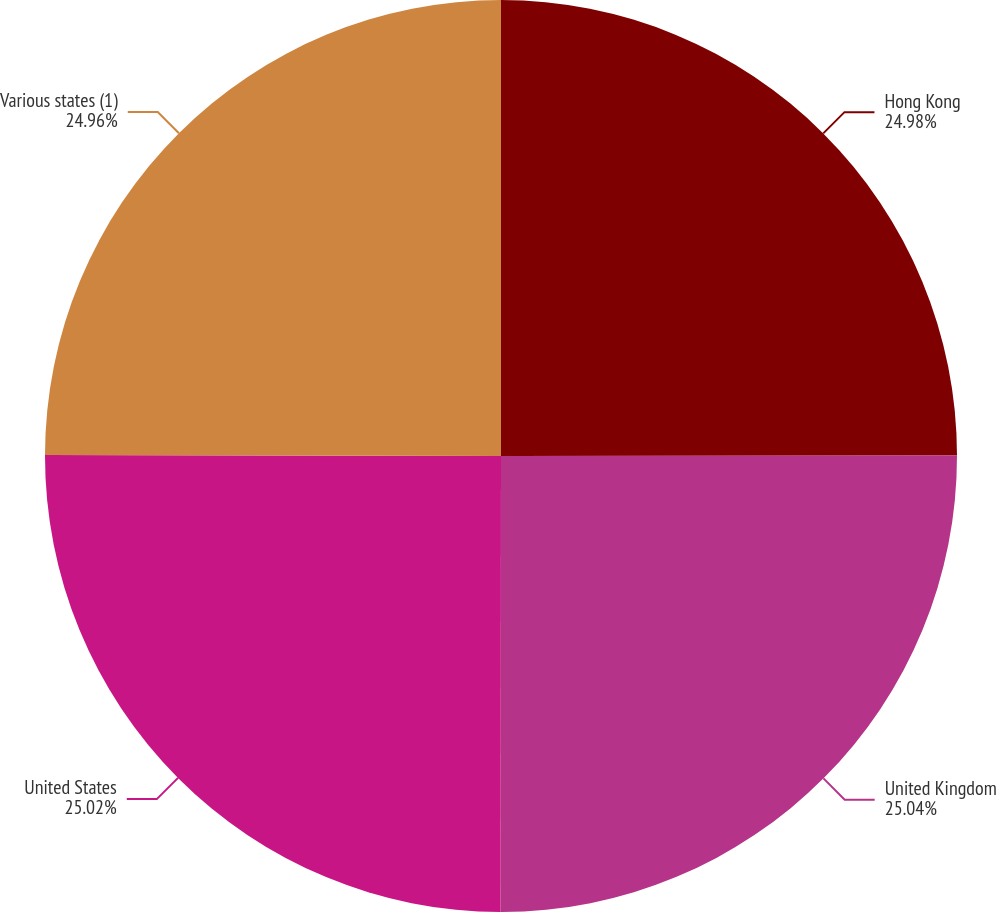Convert chart to OTSL. <chart><loc_0><loc_0><loc_500><loc_500><pie_chart><fcel>Hong Kong<fcel>United Kingdom<fcel>United States<fcel>Various states (1)<nl><fcel>24.98%<fcel>25.03%<fcel>25.02%<fcel>24.96%<nl></chart> 